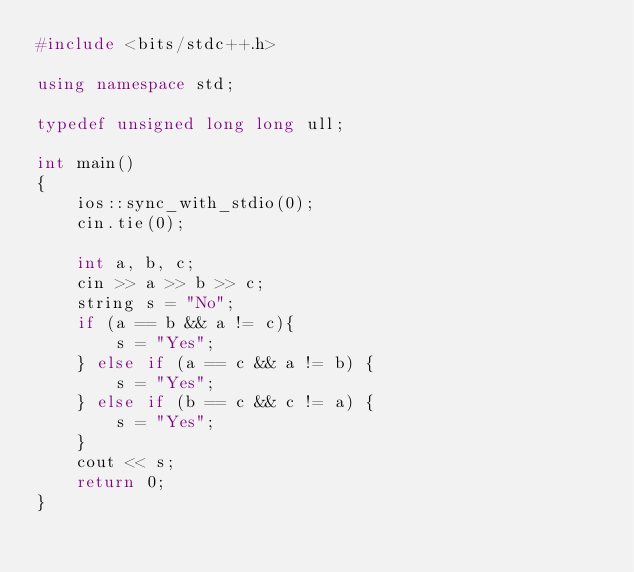<code> <loc_0><loc_0><loc_500><loc_500><_C++_>#include <bits/stdc++.h>

using namespace std;

typedef unsigned long long ull;

int main()
{
    ios::sync_with_stdio(0);
    cin.tie(0);

    int a, b, c;
    cin >> a >> b >> c;
    string s = "No";
    if (a == b && a != c){
        s = "Yes";
    } else if (a == c && a != b) {
        s = "Yes";
    } else if (b == c && c != a) {
        s = "Yes";
    }
    cout << s;
    return 0;
}</code> 